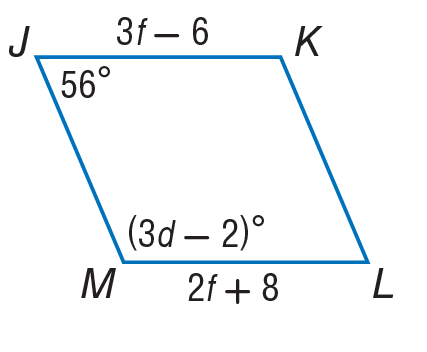Answer the mathemtical geometry problem and directly provide the correct option letter.
Question: Find the value of f in the parallelogram.
Choices: A: 14 B: 18 C: 36 D: 56 A 